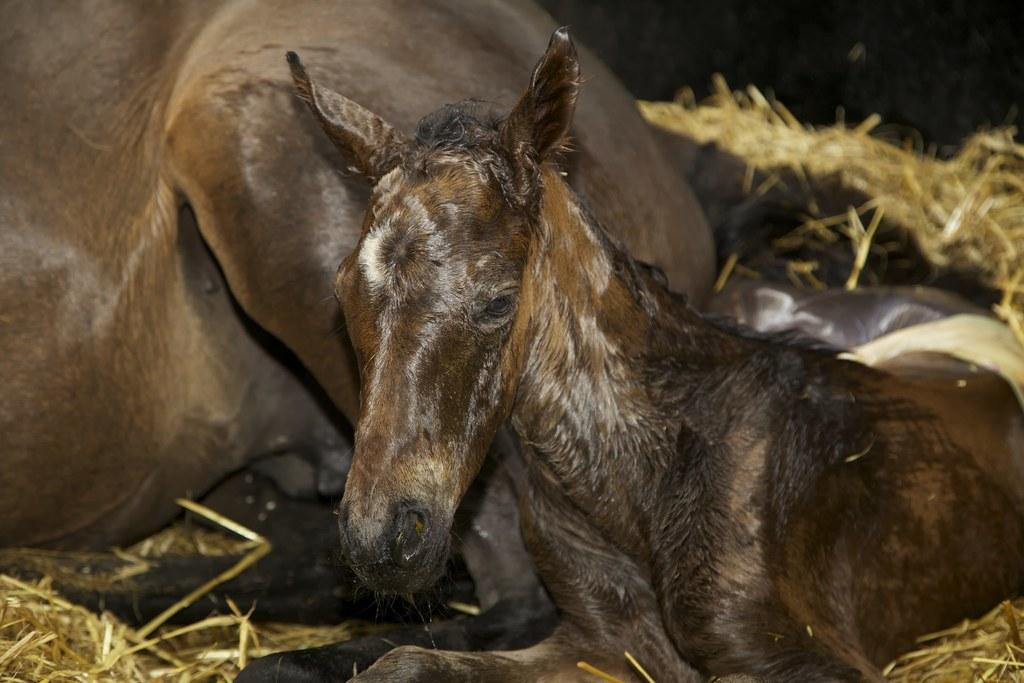What type of animals are in the image? There are brown horses in the image. What are the horses doing in the image? The horses are sitting. What type of vegetation is present in the image? There is dry grass in the image. What is the chance of the horses balancing on a van in the image? There is no van present in the image, and therefore no opportunity for the horses to balance on one. 